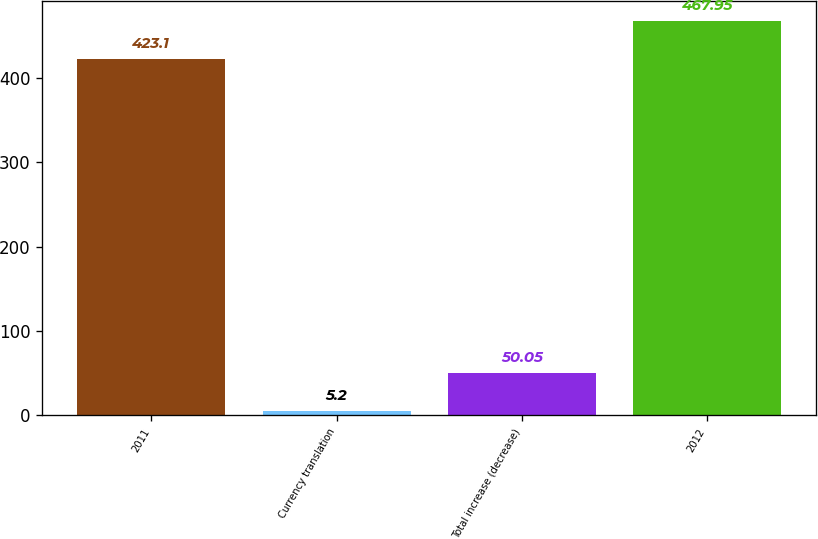<chart> <loc_0><loc_0><loc_500><loc_500><bar_chart><fcel>2011<fcel>Currency translation<fcel>Total increase (decrease)<fcel>2012<nl><fcel>423.1<fcel>5.2<fcel>50.05<fcel>467.95<nl></chart> 